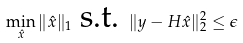Convert formula to latex. <formula><loc_0><loc_0><loc_500><loc_500>\min _ { \hat { x } } \| \hat { x } \| _ { 1 } \text { s.t. } \| y - H \hat { x } \| ^ { 2 } _ { 2 } \leq \epsilon</formula> 